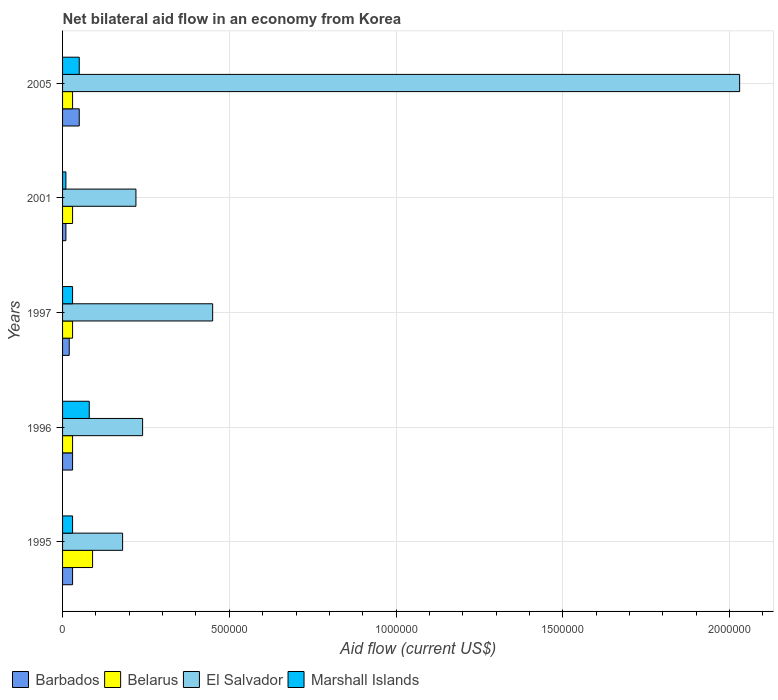How many different coloured bars are there?
Provide a short and direct response. 4. How many groups of bars are there?
Your response must be concise. 5. Are the number of bars per tick equal to the number of legend labels?
Make the answer very short. Yes. Are the number of bars on each tick of the Y-axis equal?
Make the answer very short. Yes. How many bars are there on the 1st tick from the top?
Offer a terse response. 4. In how many cases, is the number of bars for a given year not equal to the number of legend labels?
Your answer should be compact. 0. What is the net bilateral aid flow in Marshall Islands in 2005?
Your answer should be very brief. 5.00e+04. Across all years, what is the maximum net bilateral aid flow in Marshall Islands?
Give a very brief answer. 8.00e+04. Across all years, what is the minimum net bilateral aid flow in Belarus?
Offer a terse response. 3.00e+04. In which year was the net bilateral aid flow in Barbados maximum?
Your response must be concise. 2005. What is the total net bilateral aid flow in El Salvador in the graph?
Give a very brief answer. 3.12e+06. What is the difference between the net bilateral aid flow in Marshall Islands in 1996 and the net bilateral aid flow in El Salvador in 1995?
Your answer should be compact. -1.00e+05. In the year 2005, what is the difference between the net bilateral aid flow in El Salvador and net bilateral aid flow in Marshall Islands?
Provide a short and direct response. 1.98e+06. In how many years, is the net bilateral aid flow in Belarus greater than 400000 US$?
Give a very brief answer. 0. What is the difference between the highest and the second highest net bilateral aid flow in El Salvador?
Your answer should be compact. 1.58e+06. Is the sum of the net bilateral aid flow in Marshall Islands in 1995 and 1997 greater than the maximum net bilateral aid flow in El Salvador across all years?
Your response must be concise. No. Is it the case that in every year, the sum of the net bilateral aid flow in Marshall Islands and net bilateral aid flow in Belarus is greater than the sum of net bilateral aid flow in El Salvador and net bilateral aid flow in Barbados?
Make the answer very short. No. What does the 4th bar from the top in 2001 represents?
Give a very brief answer. Barbados. What does the 4th bar from the bottom in 1995 represents?
Offer a very short reply. Marshall Islands. Is it the case that in every year, the sum of the net bilateral aid flow in Barbados and net bilateral aid flow in Belarus is greater than the net bilateral aid flow in Marshall Islands?
Ensure brevity in your answer.  No. Are all the bars in the graph horizontal?
Give a very brief answer. Yes. How many years are there in the graph?
Your answer should be compact. 5. What is the difference between two consecutive major ticks on the X-axis?
Offer a terse response. 5.00e+05. Does the graph contain grids?
Your answer should be compact. Yes. How many legend labels are there?
Your response must be concise. 4. What is the title of the graph?
Ensure brevity in your answer.  Net bilateral aid flow in an economy from Korea. What is the Aid flow (current US$) of Barbados in 1995?
Make the answer very short. 3.00e+04. What is the Aid flow (current US$) in El Salvador in 1995?
Provide a short and direct response. 1.80e+05. What is the Aid flow (current US$) of Barbados in 1996?
Make the answer very short. 3.00e+04. What is the Aid flow (current US$) of Belarus in 1996?
Your response must be concise. 3.00e+04. What is the Aid flow (current US$) of El Salvador in 1996?
Provide a succinct answer. 2.40e+05. What is the Aid flow (current US$) in Barbados in 1997?
Provide a short and direct response. 2.00e+04. What is the Aid flow (current US$) in Belarus in 1997?
Provide a succinct answer. 3.00e+04. What is the Aid flow (current US$) of El Salvador in 1997?
Give a very brief answer. 4.50e+05. What is the Aid flow (current US$) of Barbados in 2001?
Your answer should be very brief. 10000. What is the Aid flow (current US$) in El Salvador in 2001?
Offer a very short reply. 2.20e+05. What is the Aid flow (current US$) of El Salvador in 2005?
Offer a terse response. 2.03e+06. Across all years, what is the maximum Aid flow (current US$) in Barbados?
Provide a succinct answer. 5.00e+04. Across all years, what is the maximum Aid flow (current US$) in El Salvador?
Your answer should be very brief. 2.03e+06. Across all years, what is the maximum Aid flow (current US$) of Marshall Islands?
Ensure brevity in your answer.  8.00e+04. Across all years, what is the minimum Aid flow (current US$) in Barbados?
Give a very brief answer. 10000. Across all years, what is the minimum Aid flow (current US$) of Belarus?
Ensure brevity in your answer.  3.00e+04. Across all years, what is the minimum Aid flow (current US$) in Marshall Islands?
Make the answer very short. 10000. What is the total Aid flow (current US$) in Barbados in the graph?
Provide a short and direct response. 1.40e+05. What is the total Aid flow (current US$) of Belarus in the graph?
Offer a terse response. 2.10e+05. What is the total Aid flow (current US$) of El Salvador in the graph?
Your response must be concise. 3.12e+06. What is the difference between the Aid flow (current US$) of Barbados in 1995 and that in 1996?
Offer a terse response. 0. What is the difference between the Aid flow (current US$) of Marshall Islands in 1995 and that in 1996?
Make the answer very short. -5.00e+04. What is the difference between the Aid flow (current US$) of Barbados in 1995 and that in 1997?
Provide a short and direct response. 10000. What is the difference between the Aid flow (current US$) of Marshall Islands in 1995 and that in 1997?
Provide a succinct answer. 0. What is the difference between the Aid flow (current US$) in Barbados in 1995 and that in 2001?
Keep it short and to the point. 2.00e+04. What is the difference between the Aid flow (current US$) in El Salvador in 1995 and that in 2005?
Offer a terse response. -1.85e+06. What is the difference between the Aid flow (current US$) of Marshall Islands in 1995 and that in 2005?
Your response must be concise. -2.00e+04. What is the difference between the Aid flow (current US$) in Barbados in 1996 and that in 1997?
Your response must be concise. 10000. What is the difference between the Aid flow (current US$) in El Salvador in 1996 and that in 1997?
Give a very brief answer. -2.10e+05. What is the difference between the Aid flow (current US$) in Belarus in 1996 and that in 2001?
Make the answer very short. 0. What is the difference between the Aid flow (current US$) in Marshall Islands in 1996 and that in 2001?
Make the answer very short. 7.00e+04. What is the difference between the Aid flow (current US$) of Barbados in 1996 and that in 2005?
Offer a very short reply. -2.00e+04. What is the difference between the Aid flow (current US$) of El Salvador in 1996 and that in 2005?
Give a very brief answer. -1.79e+06. What is the difference between the Aid flow (current US$) in Marshall Islands in 1996 and that in 2005?
Make the answer very short. 3.00e+04. What is the difference between the Aid flow (current US$) of Belarus in 1997 and that in 2001?
Offer a very short reply. 0. What is the difference between the Aid flow (current US$) of El Salvador in 1997 and that in 2001?
Provide a short and direct response. 2.30e+05. What is the difference between the Aid flow (current US$) of Marshall Islands in 1997 and that in 2001?
Provide a succinct answer. 2.00e+04. What is the difference between the Aid flow (current US$) in Belarus in 1997 and that in 2005?
Ensure brevity in your answer.  0. What is the difference between the Aid flow (current US$) of El Salvador in 1997 and that in 2005?
Provide a succinct answer. -1.58e+06. What is the difference between the Aid flow (current US$) of Marshall Islands in 1997 and that in 2005?
Provide a succinct answer. -2.00e+04. What is the difference between the Aid flow (current US$) in Barbados in 2001 and that in 2005?
Keep it short and to the point. -4.00e+04. What is the difference between the Aid flow (current US$) of Belarus in 2001 and that in 2005?
Your answer should be very brief. 0. What is the difference between the Aid flow (current US$) in El Salvador in 2001 and that in 2005?
Give a very brief answer. -1.81e+06. What is the difference between the Aid flow (current US$) of Marshall Islands in 2001 and that in 2005?
Your answer should be very brief. -4.00e+04. What is the difference between the Aid flow (current US$) in Barbados in 1995 and the Aid flow (current US$) in Belarus in 1996?
Provide a short and direct response. 0. What is the difference between the Aid flow (current US$) in Belarus in 1995 and the Aid flow (current US$) in El Salvador in 1996?
Your answer should be very brief. -1.50e+05. What is the difference between the Aid flow (current US$) in Barbados in 1995 and the Aid flow (current US$) in Belarus in 1997?
Give a very brief answer. 0. What is the difference between the Aid flow (current US$) of Barbados in 1995 and the Aid flow (current US$) of El Salvador in 1997?
Offer a terse response. -4.20e+05. What is the difference between the Aid flow (current US$) in Barbados in 1995 and the Aid flow (current US$) in Marshall Islands in 1997?
Give a very brief answer. 0. What is the difference between the Aid flow (current US$) in Belarus in 1995 and the Aid flow (current US$) in El Salvador in 1997?
Your answer should be compact. -3.60e+05. What is the difference between the Aid flow (current US$) in El Salvador in 1995 and the Aid flow (current US$) in Marshall Islands in 1997?
Give a very brief answer. 1.50e+05. What is the difference between the Aid flow (current US$) in Barbados in 1995 and the Aid flow (current US$) in Belarus in 2001?
Offer a very short reply. 0. What is the difference between the Aid flow (current US$) of Barbados in 1995 and the Aid flow (current US$) of Marshall Islands in 2001?
Provide a short and direct response. 2.00e+04. What is the difference between the Aid flow (current US$) in Belarus in 1995 and the Aid flow (current US$) in El Salvador in 2001?
Provide a short and direct response. -1.30e+05. What is the difference between the Aid flow (current US$) in Belarus in 1995 and the Aid flow (current US$) in Marshall Islands in 2001?
Your answer should be compact. 8.00e+04. What is the difference between the Aid flow (current US$) of Barbados in 1995 and the Aid flow (current US$) of El Salvador in 2005?
Offer a very short reply. -2.00e+06. What is the difference between the Aid flow (current US$) of Belarus in 1995 and the Aid flow (current US$) of El Salvador in 2005?
Your answer should be very brief. -1.94e+06. What is the difference between the Aid flow (current US$) in Belarus in 1995 and the Aid flow (current US$) in Marshall Islands in 2005?
Your answer should be compact. 4.00e+04. What is the difference between the Aid flow (current US$) in Barbados in 1996 and the Aid flow (current US$) in Belarus in 1997?
Ensure brevity in your answer.  0. What is the difference between the Aid flow (current US$) of Barbados in 1996 and the Aid flow (current US$) of El Salvador in 1997?
Give a very brief answer. -4.20e+05. What is the difference between the Aid flow (current US$) of Barbados in 1996 and the Aid flow (current US$) of Marshall Islands in 1997?
Your answer should be very brief. 0. What is the difference between the Aid flow (current US$) of Belarus in 1996 and the Aid flow (current US$) of El Salvador in 1997?
Your response must be concise. -4.20e+05. What is the difference between the Aid flow (current US$) in Belarus in 1996 and the Aid flow (current US$) in Marshall Islands in 1997?
Your answer should be very brief. 0. What is the difference between the Aid flow (current US$) of El Salvador in 1996 and the Aid flow (current US$) of Marshall Islands in 1997?
Your answer should be very brief. 2.10e+05. What is the difference between the Aid flow (current US$) in Barbados in 1996 and the Aid flow (current US$) in Marshall Islands in 2001?
Make the answer very short. 2.00e+04. What is the difference between the Aid flow (current US$) in El Salvador in 1996 and the Aid flow (current US$) in Marshall Islands in 2001?
Give a very brief answer. 2.30e+05. What is the difference between the Aid flow (current US$) of Barbados in 1996 and the Aid flow (current US$) of Belarus in 2005?
Make the answer very short. 0. What is the difference between the Aid flow (current US$) of Belarus in 1996 and the Aid flow (current US$) of Marshall Islands in 2005?
Make the answer very short. -2.00e+04. What is the difference between the Aid flow (current US$) in Barbados in 1997 and the Aid flow (current US$) in El Salvador in 2001?
Your answer should be very brief. -2.00e+05. What is the difference between the Aid flow (current US$) in Barbados in 1997 and the Aid flow (current US$) in Marshall Islands in 2001?
Ensure brevity in your answer.  10000. What is the difference between the Aid flow (current US$) in Belarus in 1997 and the Aid flow (current US$) in Marshall Islands in 2001?
Make the answer very short. 2.00e+04. What is the difference between the Aid flow (current US$) of Barbados in 1997 and the Aid flow (current US$) of El Salvador in 2005?
Provide a short and direct response. -2.01e+06. What is the difference between the Aid flow (current US$) in Barbados in 1997 and the Aid flow (current US$) in Marshall Islands in 2005?
Your answer should be compact. -3.00e+04. What is the difference between the Aid flow (current US$) in Belarus in 1997 and the Aid flow (current US$) in Marshall Islands in 2005?
Keep it short and to the point. -2.00e+04. What is the difference between the Aid flow (current US$) of El Salvador in 1997 and the Aid flow (current US$) of Marshall Islands in 2005?
Offer a terse response. 4.00e+05. What is the difference between the Aid flow (current US$) in Barbados in 2001 and the Aid flow (current US$) in El Salvador in 2005?
Give a very brief answer. -2.02e+06. What is the difference between the Aid flow (current US$) of Belarus in 2001 and the Aid flow (current US$) of Marshall Islands in 2005?
Offer a very short reply. -2.00e+04. What is the average Aid flow (current US$) in Barbados per year?
Provide a short and direct response. 2.80e+04. What is the average Aid flow (current US$) of Belarus per year?
Keep it short and to the point. 4.20e+04. What is the average Aid flow (current US$) in El Salvador per year?
Offer a very short reply. 6.24e+05. What is the average Aid flow (current US$) of Marshall Islands per year?
Your answer should be compact. 4.00e+04. In the year 1995, what is the difference between the Aid flow (current US$) of Barbados and Aid flow (current US$) of Belarus?
Give a very brief answer. -6.00e+04. In the year 1995, what is the difference between the Aid flow (current US$) in Barbados and Aid flow (current US$) in El Salvador?
Your answer should be very brief. -1.50e+05. In the year 1996, what is the difference between the Aid flow (current US$) in El Salvador and Aid flow (current US$) in Marshall Islands?
Your answer should be very brief. 1.60e+05. In the year 1997, what is the difference between the Aid flow (current US$) of Barbados and Aid flow (current US$) of Belarus?
Ensure brevity in your answer.  -10000. In the year 1997, what is the difference between the Aid flow (current US$) of Barbados and Aid flow (current US$) of El Salvador?
Keep it short and to the point. -4.30e+05. In the year 1997, what is the difference between the Aid flow (current US$) of Barbados and Aid flow (current US$) of Marshall Islands?
Your answer should be compact. -10000. In the year 1997, what is the difference between the Aid flow (current US$) in Belarus and Aid flow (current US$) in El Salvador?
Offer a terse response. -4.20e+05. In the year 1997, what is the difference between the Aid flow (current US$) in El Salvador and Aid flow (current US$) in Marshall Islands?
Your answer should be very brief. 4.20e+05. In the year 2001, what is the difference between the Aid flow (current US$) of Barbados and Aid flow (current US$) of Belarus?
Keep it short and to the point. -2.00e+04. In the year 2001, what is the difference between the Aid flow (current US$) in Barbados and Aid flow (current US$) in El Salvador?
Offer a terse response. -2.10e+05. In the year 2001, what is the difference between the Aid flow (current US$) in El Salvador and Aid flow (current US$) in Marshall Islands?
Your response must be concise. 2.10e+05. In the year 2005, what is the difference between the Aid flow (current US$) in Barbados and Aid flow (current US$) in El Salvador?
Provide a short and direct response. -1.98e+06. In the year 2005, what is the difference between the Aid flow (current US$) in Belarus and Aid flow (current US$) in Marshall Islands?
Provide a succinct answer. -2.00e+04. In the year 2005, what is the difference between the Aid flow (current US$) in El Salvador and Aid flow (current US$) in Marshall Islands?
Your response must be concise. 1.98e+06. What is the ratio of the Aid flow (current US$) in Belarus in 1995 to that in 1996?
Provide a short and direct response. 3. What is the ratio of the Aid flow (current US$) in Marshall Islands in 1995 to that in 1996?
Ensure brevity in your answer.  0.38. What is the ratio of the Aid flow (current US$) of El Salvador in 1995 to that in 1997?
Ensure brevity in your answer.  0.4. What is the ratio of the Aid flow (current US$) in Barbados in 1995 to that in 2001?
Your answer should be very brief. 3. What is the ratio of the Aid flow (current US$) of Belarus in 1995 to that in 2001?
Your response must be concise. 3. What is the ratio of the Aid flow (current US$) in El Salvador in 1995 to that in 2001?
Provide a short and direct response. 0.82. What is the ratio of the Aid flow (current US$) in Marshall Islands in 1995 to that in 2001?
Give a very brief answer. 3. What is the ratio of the Aid flow (current US$) in Belarus in 1995 to that in 2005?
Your answer should be compact. 3. What is the ratio of the Aid flow (current US$) of El Salvador in 1995 to that in 2005?
Make the answer very short. 0.09. What is the ratio of the Aid flow (current US$) in El Salvador in 1996 to that in 1997?
Make the answer very short. 0.53. What is the ratio of the Aid flow (current US$) of Marshall Islands in 1996 to that in 1997?
Give a very brief answer. 2.67. What is the ratio of the Aid flow (current US$) in Belarus in 1996 to that in 2001?
Keep it short and to the point. 1. What is the ratio of the Aid flow (current US$) of El Salvador in 1996 to that in 2001?
Keep it short and to the point. 1.09. What is the ratio of the Aid flow (current US$) in Marshall Islands in 1996 to that in 2001?
Provide a short and direct response. 8. What is the ratio of the Aid flow (current US$) in Belarus in 1996 to that in 2005?
Keep it short and to the point. 1. What is the ratio of the Aid flow (current US$) in El Salvador in 1996 to that in 2005?
Your response must be concise. 0.12. What is the ratio of the Aid flow (current US$) in Belarus in 1997 to that in 2001?
Keep it short and to the point. 1. What is the ratio of the Aid flow (current US$) in El Salvador in 1997 to that in 2001?
Keep it short and to the point. 2.05. What is the ratio of the Aid flow (current US$) in El Salvador in 1997 to that in 2005?
Offer a terse response. 0.22. What is the ratio of the Aid flow (current US$) of Barbados in 2001 to that in 2005?
Your answer should be very brief. 0.2. What is the ratio of the Aid flow (current US$) in Belarus in 2001 to that in 2005?
Offer a very short reply. 1. What is the ratio of the Aid flow (current US$) in El Salvador in 2001 to that in 2005?
Provide a short and direct response. 0.11. What is the difference between the highest and the second highest Aid flow (current US$) of Barbados?
Offer a very short reply. 2.00e+04. What is the difference between the highest and the second highest Aid flow (current US$) in Belarus?
Your response must be concise. 6.00e+04. What is the difference between the highest and the second highest Aid flow (current US$) of El Salvador?
Provide a short and direct response. 1.58e+06. What is the difference between the highest and the lowest Aid flow (current US$) in Barbados?
Offer a terse response. 4.00e+04. What is the difference between the highest and the lowest Aid flow (current US$) of Belarus?
Provide a short and direct response. 6.00e+04. What is the difference between the highest and the lowest Aid flow (current US$) of El Salvador?
Give a very brief answer. 1.85e+06. 